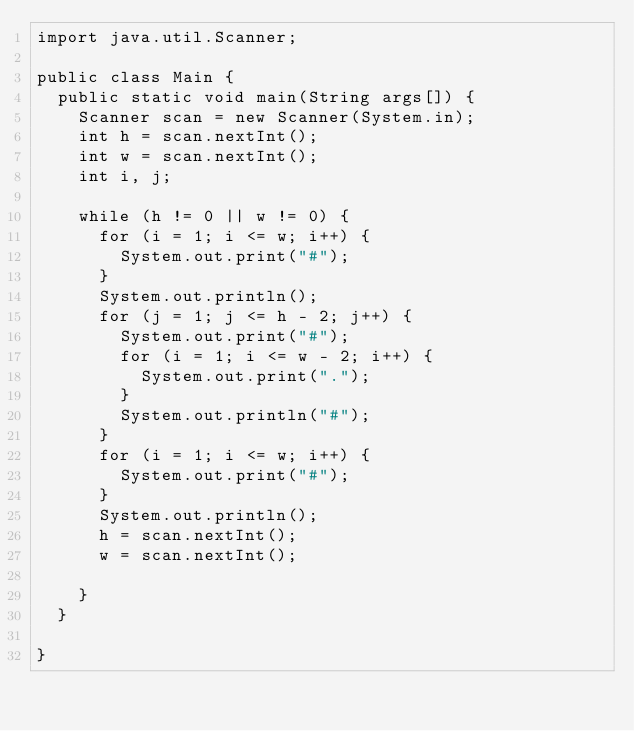Convert code to text. <code><loc_0><loc_0><loc_500><loc_500><_Java_>import java.util.Scanner;

public class Main {
	public static void main(String args[]) {
		Scanner scan = new Scanner(System.in);
		int h = scan.nextInt();
		int w = scan.nextInt();
		int i, j;

		while (h != 0 || w != 0) {
			for (i = 1; i <= w; i++) {
				System.out.print("#");
			}
			System.out.println();
			for (j = 1; j <= h - 2; j++) {
				System.out.print("#");
				for (i = 1; i <= w - 2; i++) {
					System.out.print(".");
				}
				System.out.println("#");
			}
			for (i = 1; i <= w; i++) {
				System.out.print("#");
			}
			System.out.println();
			h = scan.nextInt();
			w = scan.nextInt();

		}
	}

}</code> 